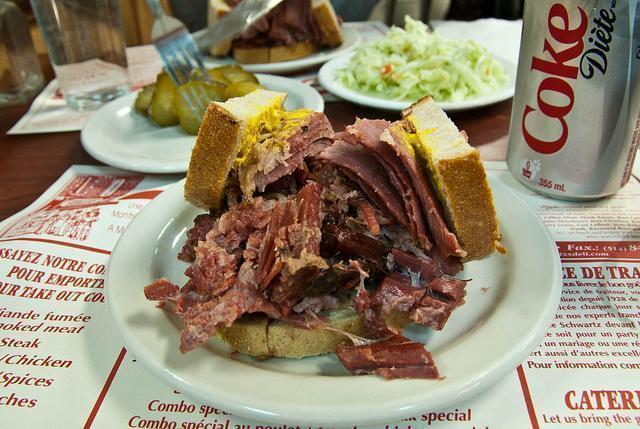What type of sandwich is this?
Select the correct answer and articulate reasoning with the following format: 'Answer: answer
Rationale: rationale.'
Options: Turkey, monte cristo, blt, corned beef. Answer: corned beef.
Rationale: The sandwich is made from thickly sliced pinkish meat. 